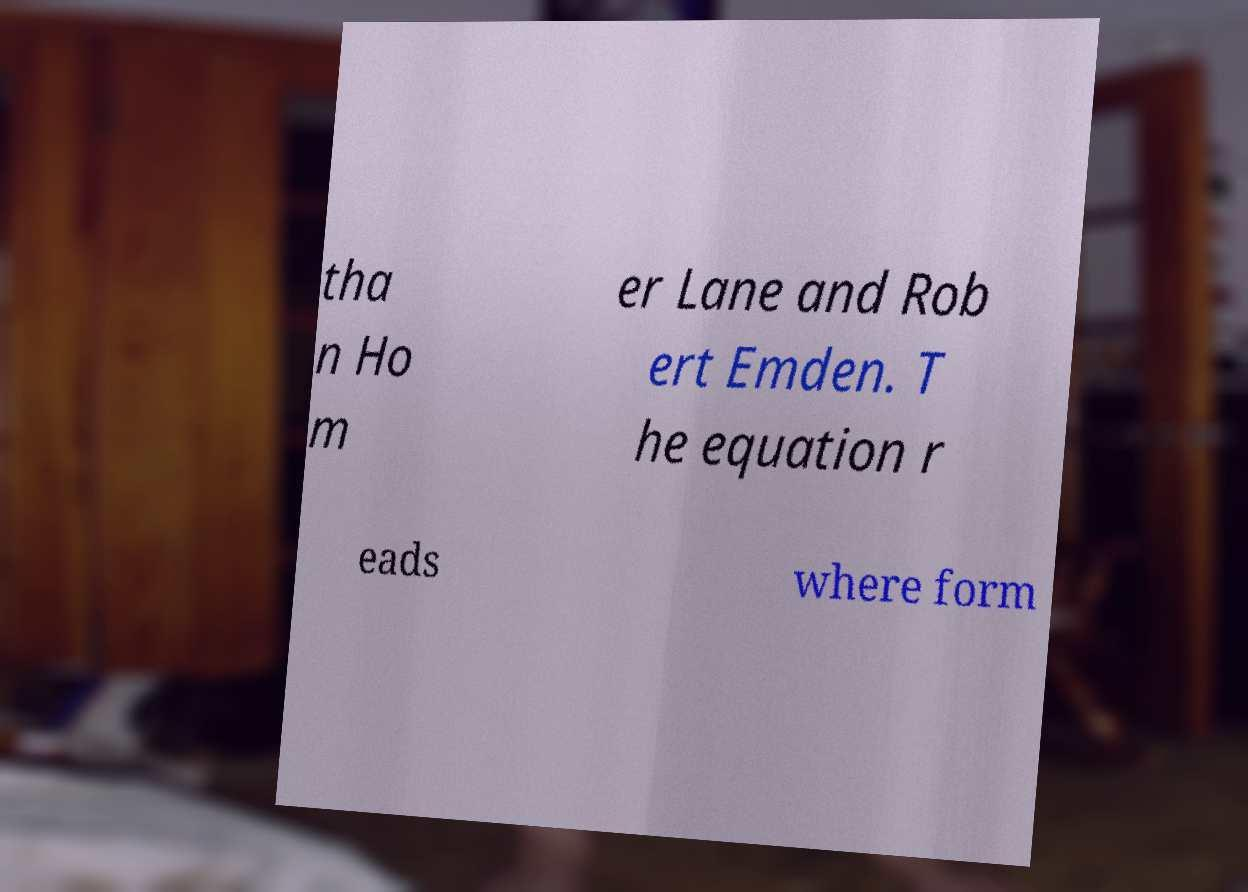Please read and relay the text visible in this image. What does it say? tha n Ho m er Lane and Rob ert Emden. T he equation r eads where form 